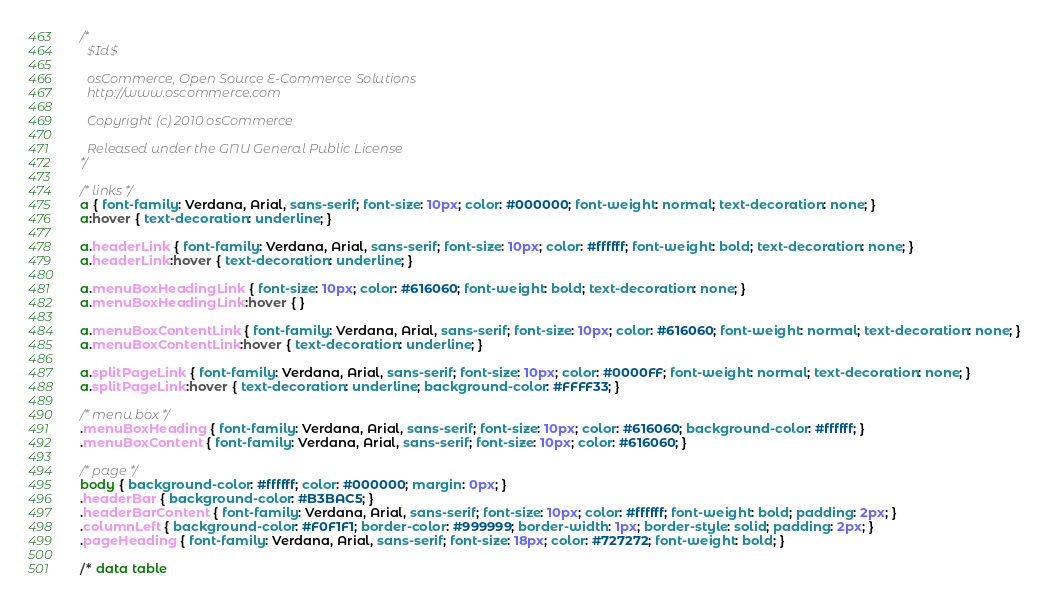Convert code to text. <code><loc_0><loc_0><loc_500><loc_500><_CSS_>/*
  $Id$

  osCommerce, Open Source E-Commerce Solutions
  http://www.oscommerce.com

  Copyright (c) 2010 osCommerce

  Released under the GNU General Public License
*/

/* links */
a { font-family: Verdana, Arial, sans-serif; font-size: 10px; color: #000000; font-weight: normal; text-decoration: none; }
a:hover { text-decoration: underline; }

a.headerLink { font-family: Verdana, Arial, sans-serif; font-size: 10px; color: #ffffff; font-weight: bold; text-decoration: none; }
a.headerLink:hover { text-decoration: underline; }

a.menuBoxHeadingLink { font-size: 10px; color: #616060; font-weight: bold; text-decoration: none; }
a.menuBoxHeadingLink:hover { }

a.menuBoxContentLink { font-family: Verdana, Arial, sans-serif; font-size: 10px; color: #616060; font-weight: normal; text-decoration: none; }
a.menuBoxContentLink:hover { text-decoration: underline; }

a.splitPageLink { font-family: Verdana, Arial, sans-serif; font-size: 10px; color: #0000FF; font-weight: normal; text-decoration: none; }
a.splitPageLink:hover { text-decoration: underline; background-color: #FFFF33; }

/* menu box */
.menuBoxHeading { font-family: Verdana, Arial, sans-serif; font-size: 10px; color: #616060; background-color: #ffffff; }
.menuBoxContent { font-family: Verdana, Arial, sans-serif; font-size: 10px; color: #616060; }

/* page */
body { background-color: #ffffff; color: #000000; margin: 0px; }
.headerBar { background-color: #B3BAC5; }
.headerBarContent { font-family: Verdana, Arial, sans-serif; font-size: 10px; color: #ffffff; font-weight: bold; padding: 2px; }
.columnLeft { background-color: #F0F1F1; border-color: #999999; border-width: 1px; border-style: solid; padding: 2px; }
.pageHeading { font-family: Verdana, Arial, sans-serif; font-size: 18px; color: #727272; font-weight: bold; }

/* data table </code> 